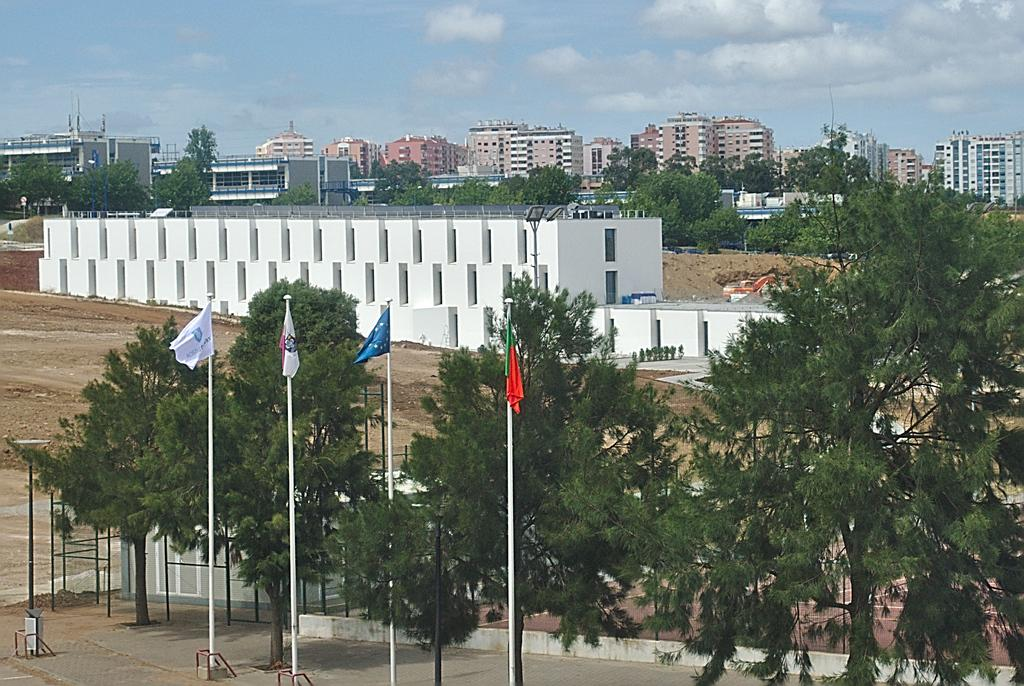What is located in the center of the image? There are flags and trees in the center of the image. What can be seen in the background of the image? There are buildings in the background of the image. What is visible at the top of the image? The sky is visible at the top of the image. How many jellyfish can be seen swimming in the image? There are no jellyfish present in the image. What type of clothing are the boys wearing in the image? There are no boys present in the image. 